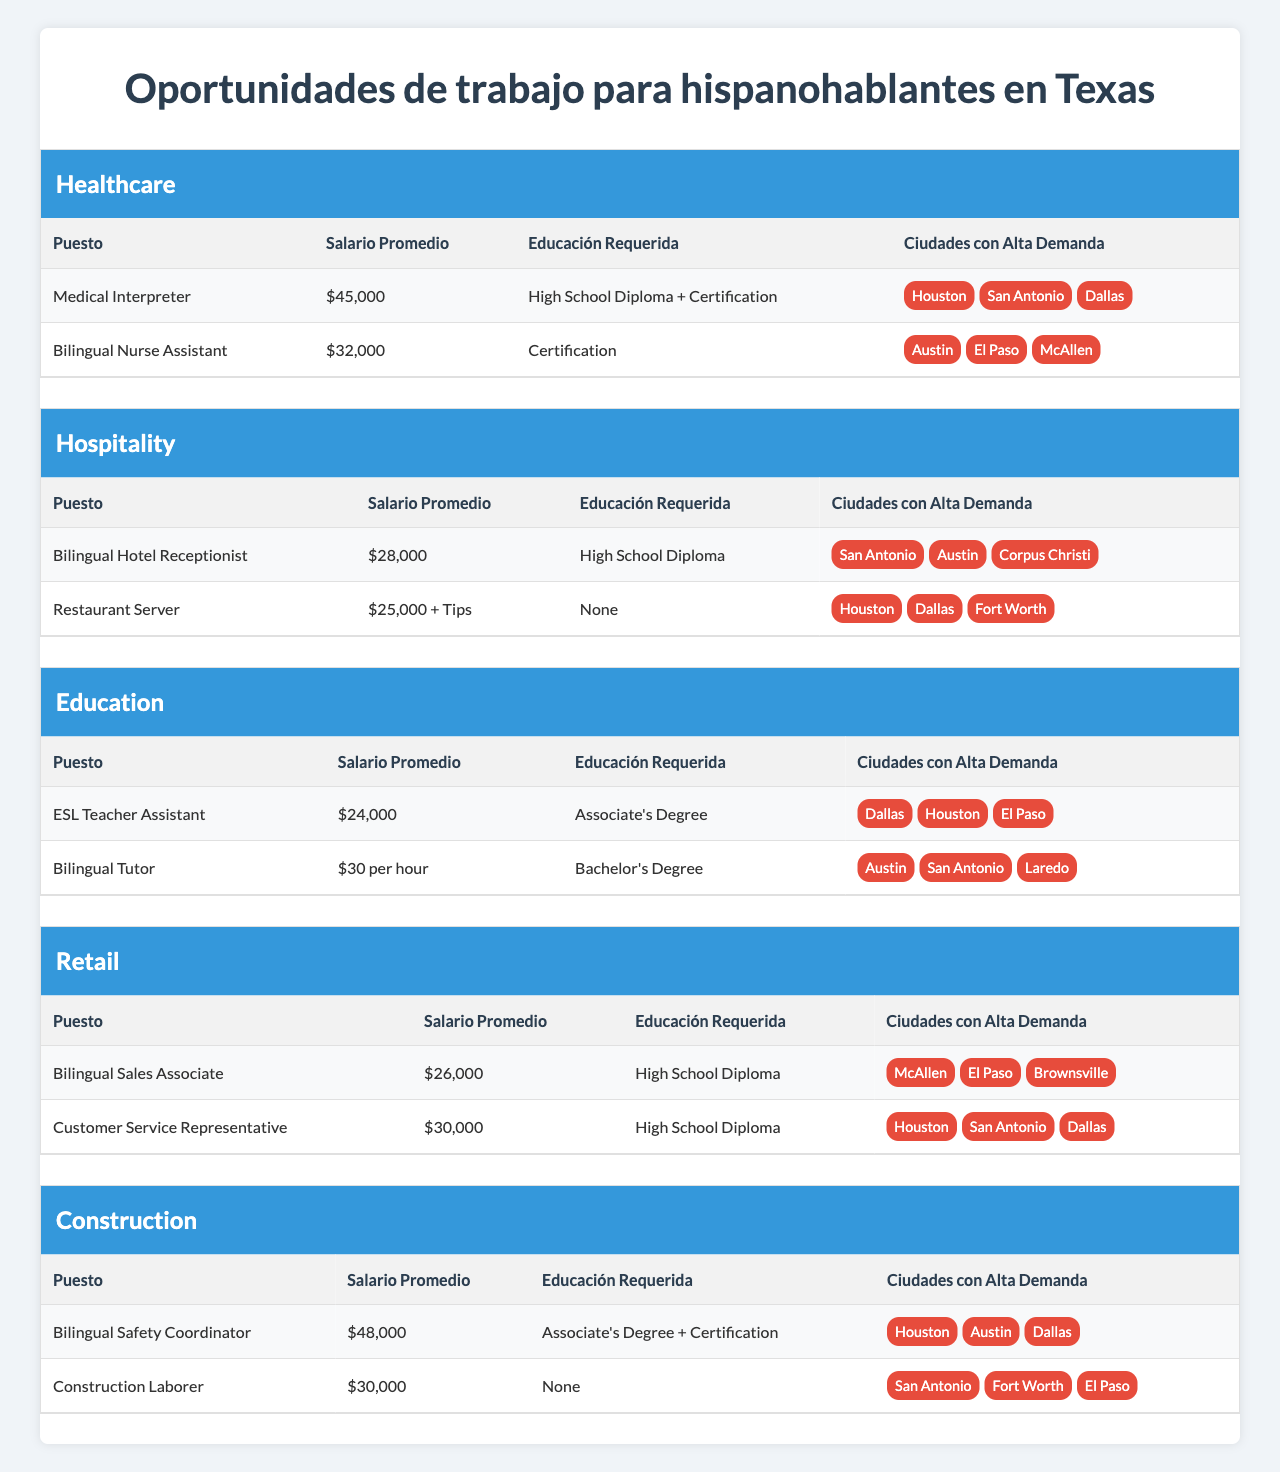What is the average salary for a Medical Interpreter? The average salary for a Medical Interpreter, as listed in the table, is $45,000.
Answer: $45,000 In which cities is the Bilingual Sales Associate job in high demand? The table shows that McAllen, El Paso, and Brownsville have high demand for the Bilingual Sales Associate position.
Answer: McAllen, El Paso, Brownsville What is the highest average salary among the listed roles? The highest average salary is for the Bilingual Safety Coordinator at $48,000, which is found in the Construction industry role section.
Answer: $48,000 Do Bilingual Hotel Receptionists require a college degree? The table indicates that a Bilingual Hotel Receptionist only requires a High School Diploma, so no college degree is necessary.
Answer: No How much more does a Medical Interpreter earn compared to a Restaurant Server? The Medical Interpreter earns $45,000, while the Restaurant Server earns $25,000 plus tips. To compare, we consider only the base salary: $45,000 - $25,000 = $20,000 more.
Answer: $20,000 Which industry offers Bilingual Nurse Assistant positions? The Bilingual Nurse Assistant role is listed under the Healthcare industry in the table.
Answer: Healthcare What is the total average salary for the roles in the Education industry? The average salaries for the roles in the Education industry are $24,000 for ESL Teacher Assistant and $30 per hour for Bilingual Tutor. The average salary of the Tutor in a year (assuming 40 hours/week for 52 weeks) is around $62,400, bringing the total to $24,000 + $62,400 = $86,400.
Answer: $86,400 In which city is there high demand for the Construction Laborer role? The cities with high demand for the Construction Laborer role are San Antonio, Fort Worth, and El Paso, as outlined in the table.
Answer: San Antonio, Fort Worth, El Paso Which job in the Hospitality industry has the lowest average salary? The Restaurant Server job has the lowest average base salary of $25,000 plus tips, lower than the Bilingual Hotel Receptionist's salary of $28,000.
Answer: Restaurant Server Is a bilingual capability important for the roles listed under the Retail industry? Yes, the roles such as Bilingual Sales Associate and Customer Service Representative specifically require bilingual capabilities, as stated in the table.
Answer: Yes 